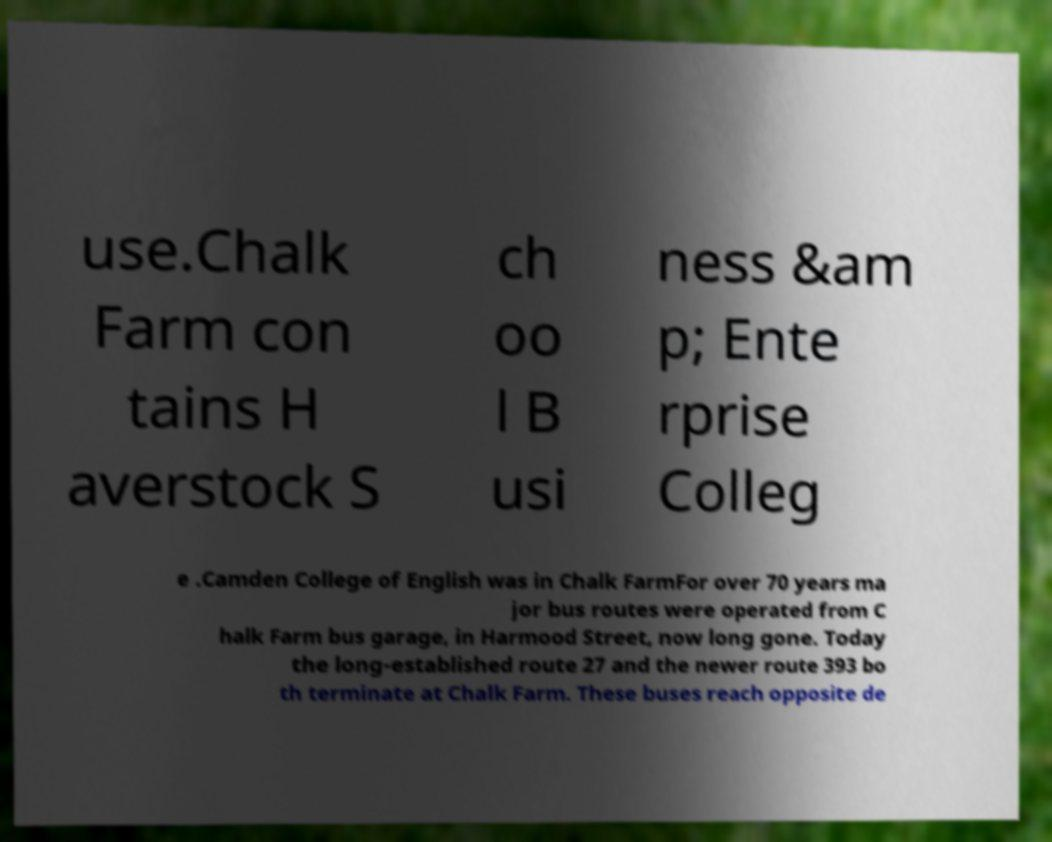Could you assist in decoding the text presented in this image and type it out clearly? use.Chalk Farm con tains H averstock S ch oo l B usi ness &am p; Ente rprise Colleg e .Camden College of English was in Chalk FarmFor over 70 years ma jor bus routes were operated from C halk Farm bus garage, in Harmood Street, now long gone. Today the long-established route 27 and the newer route 393 bo th terminate at Chalk Farm. These buses reach opposite de 